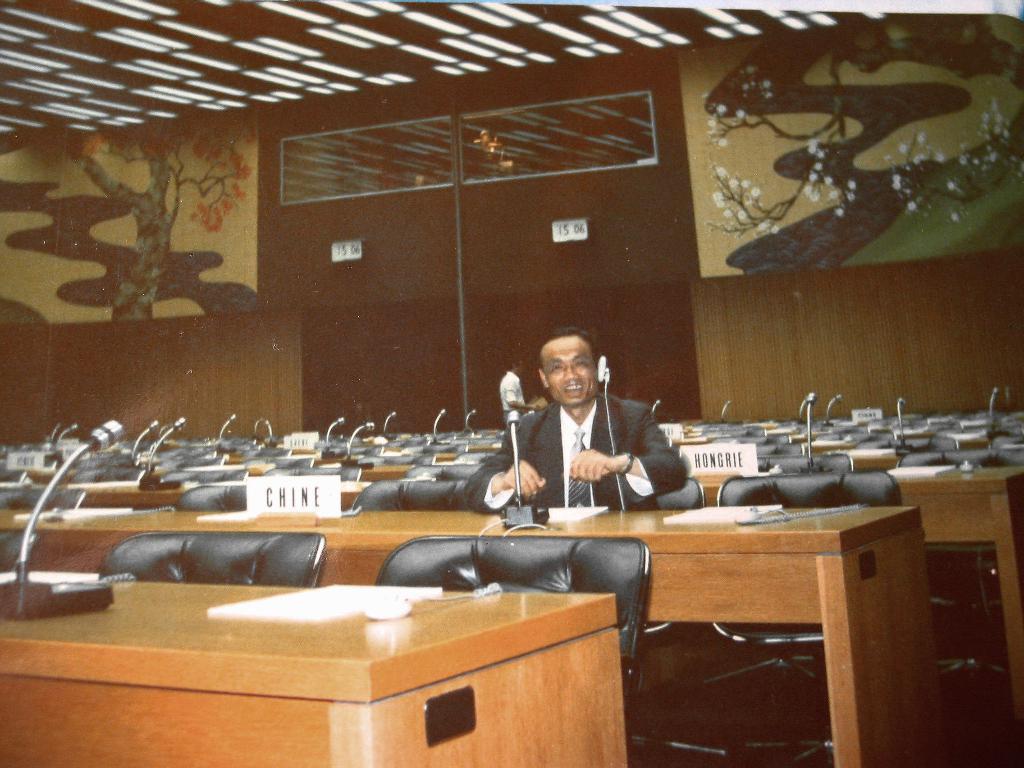Please provide a concise description of this image. In this given picture, We can see a conference hall which is fixed with mike's, chairs, lights after that, We can see a person sitting and smiling and a wall designed with trees. 